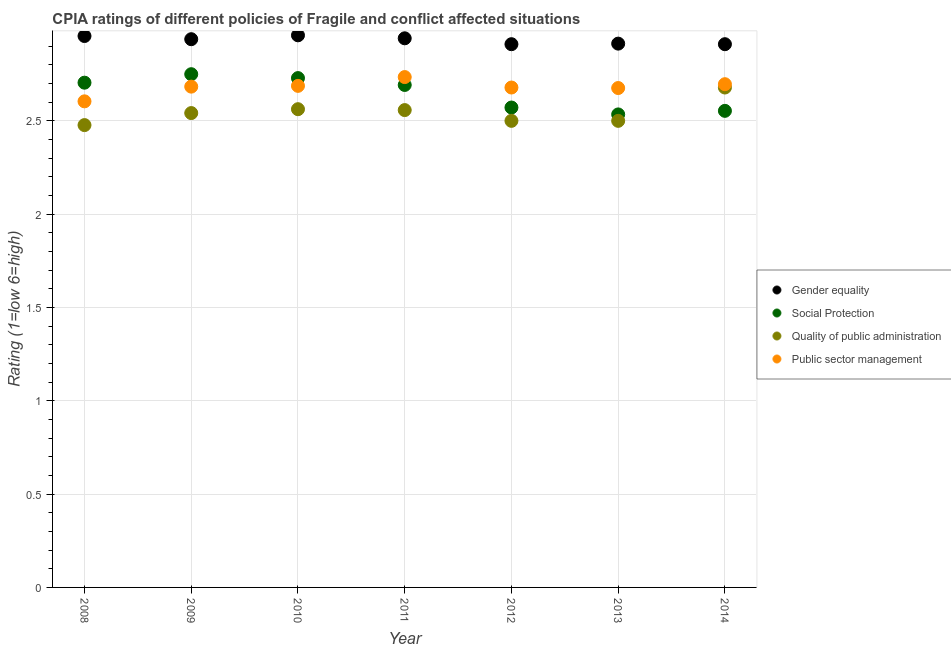How many different coloured dotlines are there?
Your response must be concise. 4. What is the cpia rating of gender equality in 2009?
Make the answer very short. 2.94. Across all years, what is the maximum cpia rating of public sector management?
Offer a terse response. 2.73. Across all years, what is the minimum cpia rating of gender equality?
Offer a terse response. 2.91. In which year was the cpia rating of gender equality maximum?
Your answer should be very brief. 2010. What is the total cpia rating of social protection in the graph?
Provide a succinct answer. 18.54. What is the difference between the cpia rating of social protection in 2011 and that in 2013?
Your response must be concise. 0.16. What is the average cpia rating of gender equality per year?
Provide a short and direct response. 2.93. In the year 2013, what is the difference between the cpia rating of social protection and cpia rating of quality of public administration?
Your answer should be very brief. 0.03. In how many years, is the cpia rating of quality of public administration greater than 2.7?
Provide a succinct answer. 0. What is the ratio of the cpia rating of public sector management in 2010 to that in 2012?
Your answer should be compact. 1. What is the difference between the highest and the second highest cpia rating of public sector management?
Provide a short and direct response. 0.04. What is the difference between the highest and the lowest cpia rating of social protection?
Offer a terse response. 0.22. Does the cpia rating of social protection monotonically increase over the years?
Your response must be concise. No. Is the cpia rating of public sector management strictly greater than the cpia rating of gender equality over the years?
Your answer should be very brief. No. Is the cpia rating of gender equality strictly less than the cpia rating of quality of public administration over the years?
Offer a very short reply. No. How many dotlines are there?
Your answer should be compact. 4. How many years are there in the graph?
Your response must be concise. 7. What is the difference between two consecutive major ticks on the Y-axis?
Ensure brevity in your answer.  0.5. Does the graph contain grids?
Your response must be concise. Yes. How many legend labels are there?
Ensure brevity in your answer.  4. How are the legend labels stacked?
Offer a terse response. Vertical. What is the title of the graph?
Your answer should be very brief. CPIA ratings of different policies of Fragile and conflict affected situations. Does "Regional development banks" appear as one of the legend labels in the graph?
Provide a short and direct response. No. What is the label or title of the X-axis?
Ensure brevity in your answer.  Year. What is the Rating (1=low 6=high) of Gender equality in 2008?
Provide a short and direct response. 2.95. What is the Rating (1=low 6=high) in Social Protection in 2008?
Provide a succinct answer. 2.7. What is the Rating (1=low 6=high) in Quality of public administration in 2008?
Your answer should be compact. 2.48. What is the Rating (1=low 6=high) in Public sector management in 2008?
Provide a succinct answer. 2.6. What is the Rating (1=low 6=high) in Gender equality in 2009?
Keep it short and to the point. 2.94. What is the Rating (1=low 6=high) in Social Protection in 2009?
Ensure brevity in your answer.  2.75. What is the Rating (1=low 6=high) in Quality of public administration in 2009?
Your response must be concise. 2.54. What is the Rating (1=low 6=high) in Public sector management in 2009?
Provide a short and direct response. 2.68. What is the Rating (1=low 6=high) in Gender equality in 2010?
Provide a short and direct response. 2.96. What is the Rating (1=low 6=high) in Social Protection in 2010?
Make the answer very short. 2.73. What is the Rating (1=low 6=high) of Quality of public administration in 2010?
Provide a short and direct response. 2.56. What is the Rating (1=low 6=high) of Public sector management in 2010?
Provide a short and direct response. 2.69. What is the Rating (1=low 6=high) of Gender equality in 2011?
Provide a succinct answer. 2.94. What is the Rating (1=low 6=high) of Social Protection in 2011?
Keep it short and to the point. 2.69. What is the Rating (1=low 6=high) of Quality of public administration in 2011?
Your answer should be compact. 2.56. What is the Rating (1=low 6=high) in Public sector management in 2011?
Give a very brief answer. 2.73. What is the Rating (1=low 6=high) of Gender equality in 2012?
Provide a succinct answer. 2.91. What is the Rating (1=low 6=high) of Social Protection in 2012?
Provide a succinct answer. 2.57. What is the Rating (1=low 6=high) in Public sector management in 2012?
Keep it short and to the point. 2.68. What is the Rating (1=low 6=high) in Gender equality in 2013?
Give a very brief answer. 2.91. What is the Rating (1=low 6=high) of Social Protection in 2013?
Your answer should be compact. 2.53. What is the Rating (1=low 6=high) in Public sector management in 2013?
Provide a succinct answer. 2.68. What is the Rating (1=low 6=high) in Gender equality in 2014?
Offer a terse response. 2.91. What is the Rating (1=low 6=high) of Social Protection in 2014?
Your answer should be very brief. 2.55. What is the Rating (1=low 6=high) of Quality of public administration in 2014?
Offer a very short reply. 2.68. What is the Rating (1=low 6=high) in Public sector management in 2014?
Your answer should be compact. 2.7. Across all years, what is the maximum Rating (1=low 6=high) in Gender equality?
Make the answer very short. 2.96. Across all years, what is the maximum Rating (1=low 6=high) in Social Protection?
Provide a succinct answer. 2.75. Across all years, what is the maximum Rating (1=low 6=high) of Quality of public administration?
Offer a very short reply. 2.68. Across all years, what is the maximum Rating (1=low 6=high) in Public sector management?
Give a very brief answer. 2.73. Across all years, what is the minimum Rating (1=low 6=high) of Gender equality?
Provide a succinct answer. 2.91. Across all years, what is the minimum Rating (1=low 6=high) of Social Protection?
Give a very brief answer. 2.53. Across all years, what is the minimum Rating (1=low 6=high) in Quality of public administration?
Ensure brevity in your answer.  2.48. Across all years, what is the minimum Rating (1=low 6=high) in Public sector management?
Keep it short and to the point. 2.6. What is the total Rating (1=low 6=high) of Gender equality in the graph?
Your answer should be very brief. 20.53. What is the total Rating (1=low 6=high) of Social Protection in the graph?
Give a very brief answer. 18.54. What is the total Rating (1=low 6=high) of Quality of public administration in the graph?
Make the answer very short. 17.82. What is the total Rating (1=low 6=high) in Public sector management in the graph?
Your answer should be very brief. 18.76. What is the difference between the Rating (1=low 6=high) of Gender equality in 2008 and that in 2009?
Ensure brevity in your answer.  0.02. What is the difference between the Rating (1=low 6=high) of Social Protection in 2008 and that in 2009?
Make the answer very short. -0.05. What is the difference between the Rating (1=low 6=high) in Quality of public administration in 2008 and that in 2009?
Give a very brief answer. -0.06. What is the difference between the Rating (1=low 6=high) in Public sector management in 2008 and that in 2009?
Your answer should be compact. -0.08. What is the difference between the Rating (1=low 6=high) of Gender equality in 2008 and that in 2010?
Your answer should be compact. -0. What is the difference between the Rating (1=low 6=high) of Social Protection in 2008 and that in 2010?
Your response must be concise. -0.02. What is the difference between the Rating (1=low 6=high) of Quality of public administration in 2008 and that in 2010?
Provide a short and direct response. -0.09. What is the difference between the Rating (1=low 6=high) of Public sector management in 2008 and that in 2010?
Offer a terse response. -0.08. What is the difference between the Rating (1=low 6=high) of Gender equality in 2008 and that in 2011?
Ensure brevity in your answer.  0.01. What is the difference between the Rating (1=low 6=high) of Social Protection in 2008 and that in 2011?
Your response must be concise. 0.01. What is the difference between the Rating (1=low 6=high) in Quality of public administration in 2008 and that in 2011?
Your answer should be very brief. -0.08. What is the difference between the Rating (1=low 6=high) in Public sector management in 2008 and that in 2011?
Make the answer very short. -0.13. What is the difference between the Rating (1=low 6=high) in Gender equality in 2008 and that in 2012?
Your answer should be very brief. 0.04. What is the difference between the Rating (1=low 6=high) in Social Protection in 2008 and that in 2012?
Keep it short and to the point. 0.13. What is the difference between the Rating (1=low 6=high) of Quality of public administration in 2008 and that in 2012?
Give a very brief answer. -0.02. What is the difference between the Rating (1=low 6=high) of Public sector management in 2008 and that in 2012?
Your answer should be compact. -0.07. What is the difference between the Rating (1=low 6=high) of Gender equality in 2008 and that in 2013?
Your answer should be very brief. 0.04. What is the difference between the Rating (1=low 6=high) of Social Protection in 2008 and that in 2013?
Provide a succinct answer. 0.17. What is the difference between the Rating (1=low 6=high) of Quality of public administration in 2008 and that in 2013?
Offer a terse response. -0.02. What is the difference between the Rating (1=low 6=high) of Public sector management in 2008 and that in 2013?
Offer a very short reply. -0.07. What is the difference between the Rating (1=low 6=high) in Gender equality in 2008 and that in 2014?
Your answer should be very brief. 0.04. What is the difference between the Rating (1=low 6=high) in Social Protection in 2008 and that in 2014?
Offer a terse response. 0.15. What is the difference between the Rating (1=low 6=high) in Quality of public administration in 2008 and that in 2014?
Provide a succinct answer. -0.2. What is the difference between the Rating (1=low 6=high) of Public sector management in 2008 and that in 2014?
Give a very brief answer. -0.09. What is the difference between the Rating (1=low 6=high) in Gender equality in 2009 and that in 2010?
Give a very brief answer. -0.02. What is the difference between the Rating (1=low 6=high) in Social Protection in 2009 and that in 2010?
Your answer should be very brief. 0.02. What is the difference between the Rating (1=low 6=high) of Quality of public administration in 2009 and that in 2010?
Offer a very short reply. -0.02. What is the difference between the Rating (1=low 6=high) of Public sector management in 2009 and that in 2010?
Provide a short and direct response. -0. What is the difference between the Rating (1=low 6=high) in Gender equality in 2009 and that in 2011?
Your answer should be compact. -0. What is the difference between the Rating (1=low 6=high) in Social Protection in 2009 and that in 2011?
Your answer should be compact. 0.06. What is the difference between the Rating (1=low 6=high) of Quality of public administration in 2009 and that in 2011?
Give a very brief answer. -0.02. What is the difference between the Rating (1=low 6=high) in Public sector management in 2009 and that in 2011?
Provide a short and direct response. -0.05. What is the difference between the Rating (1=low 6=high) in Gender equality in 2009 and that in 2012?
Your response must be concise. 0.03. What is the difference between the Rating (1=low 6=high) of Social Protection in 2009 and that in 2012?
Ensure brevity in your answer.  0.18. What is the difference between the Rating (1=low 6=high) in Quality of public administration in 2009 and that in 2012?
Your answer should be very brief. 0.04. What is the difference between the Rating (1=low 6=high) of Public sector management in 2009 and that in 2012?
Provide a succinct answer. 0. What is the difference between the Rating (1=low 6=high) in Gender equality in 2009 and that in 2013?
Give a very brief answer. 0.02. What is the difference between the Rating (1=low 6=high) of Social Protection in 2009 and that in 2013?
Your response must be concise. 0.22. What is the difference between the Rating (1=low 6=high) of Quality of public administration in 2009 and that in 2013?
Your answer should be very brief. 0.04. What is the difference between the Rating (1=low 6=high) of Public sector management in 2009 and that in 2013?
Offer a very short reply. 0.01. What is the difference between the Rating (1=low 6=high) in Gender equality in 2009 and that in 2014?
Your answer should be compact. 0.03. What is the difference between the Rating (1=low 6=high) of Social Protection in 2009 and that in 2014?
Provide a succinct answer. 0.2. What is the difference between the Rating (1=low 6=high) of Quality of public administration in 2009 and that in 2014?
Make the answer very short. -0.14. What is the difference between the Rating (1=low 6=high) of Public sector management in 2009 and that in 2014?
Your response must be concise. -0.01. What is the difference between the Rating (1=low 6=high) in Gender equality in 2010 and that in 2011?
Provide a short and direct response. 0.02. What is the difference between the Rating (1=low 6=high) in Social Protection in 2010 and that in 2011?
Your answer should be very brief. 0.04. What is the difference between the Rating (1=low 6=high) in Quality of public administration in 2010 and that in 2011?
Provide a short and direct response. 0. What is the difference between the Rating (1=low 6=high) in Public sector management in 2010 and that in 2011?
Keep it short and to the point. -0.05. What is the difference between the Rating (1=low 6=high) of Gender equality in 2010 and that in 2012?
Provide a succinct answer. 0.05. What is the difference between the Rating (1=low 6=high) in Social Protection in 2010 and that in 2012?
Your answer should be compact. 0.16. What is the difference between the Rating (1=low 6=high) of Quality of public administration in 2010 and that in 2012?
Your answer should be very brief. 0.06. What is the difference between the Rating (1=low 6=high) of Public sector management in 2010 and that in 2012?
Ensure brevity in your answer.  0.01. What is the difference between the Rating (1=low 6=high) in Gender equality in 2010 and that in 2013?
Offer a very short reply. 0.04. What is the difference between the Rating (1=low 6=high) of Social Protection in 2010 and that in 2013?
Your response must be concise. 0.19. What is the difference between the Rating (1=low 6=high) of Quality of public administration in 2010 and that in 2013?
Your answer should be very brief. 0.06. What is the difference between the Rating (1=low 6=high) of Public sector management in 2010 and that in 2013?
Offer a very short reply. 0.01. What is the difference between the Rating (1=low 6=high) in Gender equality in 2010 and that in 2014?
Keep it short and to the point. 0.05. What is the difference between the Rating (1=low 6=high) of Social Protection in 2010 and that in 2014?
Keep it short and to the point. 0.18. What is the difference between the Rating (1=low 6=high) of Quality of public administration in 2010 and that in 2014?
Ensure brevity in your answer.  -0.12. What is the difference between the Rating (1=low 6=high) in Public sector management in 2010 and that in 2014?
Give a very brief answer. -0.01. What is the difference between the Rating (1=low 6=high) of Gender equality in 2011 and that in 2012?
Provide a succinct answer. 0.03. What is the difference between the Rating (1=low 6=high) of Social Protection in 2011 and that in 2012?
Keep it short and to the point. 0.12. What is the difference between the Rating (1=low 6=high) of Quality of public administration in 2011 and that in 2012?
Make the answer very short. 0.06. What is the difference between the Rating (1=low 6=high) in Public sector management in 2011 and that in 2012?
Offer a terse response. 0.06. What is the difference between the Rating (1=low 6=high) in Gender equality in 2011 and that in 2013?
Your answer should be very brief. 0.03. What is the difference between the Rating (1=low 6=high) of Social Protection in 2011 and that in 2013?
Your answer should be very brief. 0.16. What is the difference between the Rating (1=low 6=high) in Quality of public administration in 2011 and that in 2013?
Offer a terse response. 0.06. What is the difference between the Rating (1=low 6=high) of Public sector management in 2011 and that in 2013?
Your answer should be compact. 0.06. What is the difference between the Rating (1=low 6=high) of Gender equality in 2011 and that in 2014?
Offer a terse response. 0.03. What is the difference between the Rating (1=low 6=high) of Social Protection in 2011 and that in 2014?
Your response must be concise. 0.14. What is the difference between the Rating (1=low 6=high) in Quality of public administration in 2011 and that in 2014?
Ensure brevity in your answer.  -0.12. What is the difference between the Rating (1=low 6=high) in Public sector management in 2011 and that in 2014?
Your response must be concise. 0.04. What is the difference between the Rating (1=low 6=high) of Gender equality in 2012 and that in 2013?
Give a very brief answer. -0. What is the difference between the Rating (1=low 6=high) in Social Protection in 2012 and that in 2013?
Offer a terse response. 0.04. What is the difference between the Rating (1=low 6=high) in Public sector management in 2012 and that in 2013?
Provide a succinct answer. 0. What is the difference between the Rating (1=low 6=high) of Social Protection in 2012 and that in 2014?
Your answer should be very brief. 0.02. What is the difference between the Rating (1=low 6=high) in Quality of public administration in 2012 and that in 2014?
Offer a very short reply. -0.18. What is the difference between the Rating (1=low 6=high) of Public sector management in 2012 and that in 2014?
Ensure brevity in your answer.  -0.02. What is the difference between the Rating (1=low 6=high) of Gender equality in 2013 and that in 2014?
Your answer should be compact. 0. What is the difference between the Rating (1=low 6=high) of Social Protection in 2013 and that in 2014?
Give a very brief answer. -0.02. What is the difference between the Rating (1=low 6=high) of Quality of public administration in 2013 and that in 2014?
Provide a short and direct response. -0.18. What is the difference between the Rating (1=low 6=high) in Public sector management in 2013 and that in 2014?
Ensure brevity in your answer.  -0.02. What is the difference between the Rating (1=low 6=high) in Gender equality in 2008 and the Rating (1=low 6=high) in Social Protection in 2009?
Offer a terse response. 0.2. What is the difference between the Rating (1=low 6=high) in Gender equality in 2008 and the Rating (1=low 6=high) in Quality of public administration in 2009?
Provide a short and direct response. 0.41. What is the difference between the Rating (1=low 6=high) in Gender equality in 2008 and the Rating (1=low 6=high) in Public sector management in 2009?
Provide a short and direct response. 0.27. What is the difference between the Rating (1=low 6=high) of Social Protection in 2008 and the Rating (1=low 6=high) of Quality of public administration in 2009?
Offer a terse response. 0.16. What is the difference between the Rating (1=low 6=high) of Social Protection in 2008 and the Rating (1=low 6=high) of Public sector management in 2009?
Your response must be concise. 0.02. What is the difference between the Rating (1=low 6=high) of Quality of public administration in 2008 and the Rating (1=low 6=high) of Public sector management in 2009?
Provide a succinct answer. -0.21. What is the difference between the Rating (1=low 6=high) of Gender equality in 2008 and the Rating (1=low 6=high) of Social Protection in 2010?
Your answer should be compact. 0.23. What is the difference between the Rating (1=low 6=high) of Gender equality in 2008 and the Rating (1=low 6=high) of Quality of public administration in 2010?
Provide a short and direct response. 0.39. What is the difference between the Rating (1=low 6=high) of Gender equality in 2008 and the Rating (1=low 6=high) of Public sector management in 2010?
Provide a succinct answer. 0.27. What is the difference between the Rating (1=low 6=high) of Social Protection in 2008 and the Rating (1=low 6=high) of Quality of public administration in 2010?
Your answer should be very brief. 0.14. What is the difference between the Rating (1=low 6=high) of Social Protection in 2008 and the Rating (1=low 6=high) of Public sector management in 2010?
Ensure brevity in your answer.  0.02. What is the difference between the Rating (1=low 6=high) in Quality of public administration in 2008 and the Rating (1=low 6=high) in Public sector management in 2010?
Offer a terse response. -0.21. What is the difference between the Rating (1=low 6=high) of Gender equality in 2008 and the Rating (1=low 6=high) of Social Protection in 2011?
Offer a terse response. 0.26. What is the difference between the Rating (1=low 6=high) of Gender equality in 2008 and the Rating (1=low 6=high) of Quality of public administration in 2011?
Provide a succinct answer. 0.4. What is the difference between the Rating (1=low 6=high) of Gender equality in 2008 and the Rating (1=low 6=high) of Public sector management in 2011?
Your response must be concise. 0.22. What is the difference between the Rating (1=low 6=high) of Social Protection in 2008 and the Rating (1=low 6=high) of Quality of public administration in 2011?
Ensure brevity in your answer.  0.15. What is the difference between the Rating (1=low 6=high) in Social Protection in 2008 and the Rating (1=low 6=high) in Public sector management in 2011?
Offer a very short reply. -0.03. What is the difference between the Rating (1=low 6=high) of Quality of public administration in 2008 and the Rating (1=low 6=high) of Public sector management in 2011?
Ensure brevity in your answer.  -0.26. What is the difference between the Rating (1=low 6=high) of Gender equality in 2008 and the Rating (1=low 6=high) of Social Protection in 2012?
Offer a terse response. 0.38. What is the difference between the Rating (1=low 6=high) in Gender equality in 2008 and the Rating (1=low 6=high) in Quality of public administration in 2012?
Offer a terse response. 0.45. What is the difference between the Rating (1=low 6=high) of Gender equality in 2008 and the Rating (1=low 6=high) of Public sector management in 2012?
Ensure brevity in your answer.  0.28. What is the difference between the Rating (1=low 6=high) in Social Protection in 2008 and the Rating (1=low 6=high) in Quality of public administration in 2012?
Keep it short and to the point. 0.2. What is the difference between the Rating (1=low 6=high) in Social Protection in 2008 and the Rating (1=low 6=high) in Public sector management in 2012?
Make the answer very short. 0.03. What is the difference between the Rating (1=low 6=high) of Quality of public administration in 2008 and the Rating (1=low 6=high) of Public sector management in 2012?
Your response must be concise. -0.2. What is the difference between the Rating (1=low 6=high) in Gender equality in 2008 and the Rating (1=low 6=high) in Social Protection in 2013?
Give a very brief answer. 0.42. What is the difference between the Rating (1=low 6=high) of Gender equality in 2008 and the Rating (1=low 6=high) of Quality of public administration in 2013?
Your answer should be compact. 0.45. What is the difference between the Rating (1=low 6=high) of Gender equality in 2008 and the Rating (1=low 6=high) of Public sector management in 2013?
Make the answer very short. 0.28. What is the difference between the Rating (1=low 6=high) in Social Protection in 2008 and the Rating (1=low 6=high) in Quality of public administration in 2013?
Offer a very short reply. 0.2. What is the difference between the Rating (1=low 6=high) of Social Protection in 2008 and the Rating (1=low 6=high) of Public sector management in 2013?
Your answer should be very brief. 0.03. What is the difference between the Rating (1=low 6=high) in Quality of public administration in 2008 and the Rating (1=low 6=high) in Public sector management in 2013?
Offer a very short reply. -0.2. What is the difference between the Rating (1=low 6=high) of Gender equality in 2008 and the Rating (1=low 6=high) of Social Protection in 2014?
Ensure brevity in your answer.  0.4. What is the difference between the Rating (1=low 6=high) in Gender equality in 2008 and the Rating (1=low 6=high) in Quality of public administration in 2014?
Offer a terse response. 0.28. What is the difference between the Rating (1=low 6=high) of Gender equality in 2008 and the Rating (1=low 6=high) of Public sector management in 2014?
Give a very brief answer. 0.26. What is the difference between the Rating (1=low 6=high) of Social Protection in 2008 and the Rating (1=low 6=high) of Quality of public administration in 2014?
Give a very brief answer. 0.03. What is the difference between the Rating (1=low 6=high) in Social Protection in 2008 and the Rating (1=low 6=high) in Public sector management in 2014?
Your answer should be very brief. 0.01. What is the difference between the Rating (1=low 6=high) in Quality of public administration in 2008 and the Rating (1=low 6=high) in Public sector management in 2014?
Offer a terse response. -0.22. What is the difference between the Rating (1=low 6=high) of Gender equality in 2009 and the Rating (1=low 6=high) of Social Protection in 2010?
Give a very brief answer. 0.21. What is the difference between the Rating (1=low 6=high) of Social Protection in 2009 and the Rating (1=low 6=high) of Quality of public administration in 2010?
Offer a very short reply. 0.19. What is the difference between the Rating (1=low 6=high) of Social Protection in 2009 and the Rating (1=low 6=high) of Public sector management in 2010?
Ensure brevity in your answer.  0.06. What is the difference between the Rating (1=low 6=high) of Quality of public administration in 2009 and the Rating (1=low 6=high) of Public sector management in 2010?
Ensure brevity in your answer.  -0.15. What is the difference between the Rating (1=low 6=high) in Gender equality in 2009 and the Rating (1=low 6=high) in Social Protection in 2011?
Offer a very short reply. 0.25. What is the difference between the Rating (1=low 6=high) of Gender equality in 2009 and the Rating (1=low 6=high) of Quality of public administration in 2011?
Keep it short and to the point. 0.38. What is the difference between the Rating (1=low 6=high) in Gender equality in 2009 and the Rating (1=low 6=high) in Public sector management in 2011?
Your answer should be very brief. 0.2. What is the difference between the Rating (1=low 6=high) in Social Protection in 2009 and the Rating (1=low 6=high) in Quality of public administration in 2011?
Make the answer very short. 0.19. What is the difference between the Rating (1=low 6=high) in Social Protection in 2009 and the Rating (1=low 6=high) in Public sector management in 2011?
Your answer should be compact. 0.02. What is the difference between the Rating (1=low 6=high) of Quality of public administration in 2009 and the Rating (1=low 6=high) of Public sector management in 2011?
Keep it short and to the point. -0.19. What is the difference between the Rating (1=low 6=high) of Gender equality in 2009 and the Rating (1=low 6=high) of Social Protection in 2012?
Provide a succinct answer. 0.37. What is the difference between the Rating (1=low 6=high) in Gender equality in 2009 and the Rating (1=low 6=high) in Quality of public administration in 2012?
Provide a succinct answer. 0.44. What is the difference between the Rating (1=low 6=high) in Gender equality in 2009 and the Rating (1=low 6=high) in Public sector management in 2012?
Provide a short and direct response. 0.26. What is the difference between the Rating (1=low 6=high) in Social Protection in 2009 and the Rating (1=low 6=high) in Quality of public administration in 2012?
Your answer should be compact. 0.25. What is the difference between the Rating (1=low 6=high) in Social Protection in 2009 and the Rating (1=low 6=high) in Public sector management in 2012?
Give a very brief answer. 0.07. What is the difference between the Rating (1=low 6=high) in Quality of public administration in 2009 and the Rating (1=low 6=high) in Public sector management in 2012?
Make the answer very short. -0.14. What is the difference between the Rating (1=low 6=high) in Gender equality in 2009 and the Rating (1=low 6=high) in Social Protection in 2013?
Offer a terse response. 0.4. What is the difference between the Rating (1=low 6=high) in Gender equality in 2009 and the Rating (1=low 6=high) in Quality of public administration in 2013?
Ensure brevity in your answer.  0.44. What is the difference between the Rating (1=low 6=high) of Gender equality in 2009 and the Rating (1=low 6=high) of Public sector management in 2013?
Your answer should be compact. 0.26. What is the difference between the Rating (1=low 6=high) in Social Protection in 2009 and the Rating (1=low 6=high) in Quality of public administration in 2013?
Provide a succinct answer. 0.25. What is the difference between the Rating (1=low 6=high) in Social Protection in 2009 and the Rating (1=low 6=high) in Public sector management in 2013?
Offer a very short reply. 0.07. What is the difference between the Rating (1=low 6=high) in Quality of public administration in 2009 and the Rating (1=low 6=high) in Public sector management in 2013?
Your response must be concise. -0.13. What is the difference between the Rating (1=low 6=high) of Gender equality in 2009 and the Rating (1=low 6=high) of Social Protection in 2014?
Provide a succinct answer. 0.38. What is the difference between the Rating (1=low 6=high) in Gender equality in 2009 and the Rating (1=low 6=high) in Quality of public administration in 2014?
Provide a short and direct response. 0.26. What is the difference between the Rating (1=low 6=high) of Gender equality in 2009 and the Rating (1=low 6=high) of Public sector management in 2014?
Your answer should be very brief. 0.24. What is the difference between the Rating (1=low 6=high) in Social Protection in 2009 and the Rating (1=low 6=high) in Quality of public administration in 2014?
Give a very brief answer. 0.07. What is the difference between the Rating (1=low 6=high) of Social Protection in 2009 and the Rating (1=low 6=high) of Public sector management in 2014?
Your response must be concise. 0.05. What is the difference between the Rating (1=low 6=high) in Quality of public administration in 2009 and the Rating (1=low 6=high) in Public sector management in 2014?
Your answer should be compact. -0.15. What is the difference between the Rating (1=low 6=high) of Gender equality in 2010 and the Rating (1=low 6=high) of Social Protection in 2011?
Offer a terse response. 0.27. What is the difference between the Rating (1=low 6=high) in Gender equality in 2010 and the Rating (1=low 6=high) in Quality of public administration in 2011?
Ensure brevity in your answer.  0.4. What is the difference between the Rating (1=low 6=high) in Gender equality in 2010 and the Rating (1=low 6=high) in Public sector management in 2011?
Keep it short and to the point. 0.22. What is the difference between the Rating (1=low 6=high) in Social Protection in 2010 and the Rating (1=low 6=high) in Quality of public administration in 2011?
Keep it short and to the point. 0.17. What is the difference between the Rating (1=low 6=high) in Social Protection in 2010 and the Rating (1=low 6=high) in Public sector management in 2011?
Your answer should be compact. -0.01. What is the difference between the Rating (1=low 6=high) in Quality of public administration in 2010 and the Rating (1=low 6=high) in Public sector management in 2011?
Provide a short and direct response. -0.17. What is the difference between the Rating (1=low 6=high) in Gender equality in 2010 and the Rating (1=low 6=high) in Social Protection in 2012?
Give a very brief answer. 0.39. What is the difference between the Rating (1=low 6=high) in Gender equality in 2010 and the Rating (1=low 6=high) in Quality of public administration in 2012?
Offer a terse response. 0.46. What is the difference between the Rating (1=low 6=high) in Gender equality in 2010 and the Rating (1=low 6=high) in Public sector management in 2012?
Your answer should be very brief. 0.28. What is the difference between the Rating (1=low 6=high) of Social Protection in 2010 and the Rating (1=low 6=high) of Quality of public administration in 2012?
Provide a short and direct response. 0.23. What is the difference between the Rating (1=low 6=high) in Social Protection in 2010 and the Rating (1=low 6=high) in Public sector management in 2012?
Ensure brevity in your answer.  0.05. What is the difference between the Rating (1=low 6=high) in Quality of public administration in 2010 and the Rating (1=low 6=high) in Public sector management in 2012?
Offer a very short reply. -0.12. What is the difference between the Rating (1=low 6=high) in Gender equality in 2010 and the Rating (1=low 6=high) in Social Protection in 2013?
Provide a short and direct response. 0.42. What is the difference between the Rating (1=low 6=high) of Gender equality in 2010 and the Rating (1=low 6=high) of Quality of public administration in 2013?
Offer a very short reply. 0.46. What is the difference between the Rating (1=low 6=high) in Gender equality in 2010 and the Rating (1=low 6=high) in Public sector management in 2013?
Provide a succinct answer. 0.28. What is the difference between the Rating (1=low 6=high) of Social Protection in 2010 and the Rating (1=low 6=high) of Quality of public administration in 2013?
Your answer should be very brief. 0.23. What is the difference between the Rating (1=low 6=high) of Social Protection in 2010 and the Rating (1=low 6=high) of Public sector management in 2013?
Provide a short and direct response. 0.05. What is the difference between the Rating (1=low 6=high) in Quality of public administration in 2010 and the Rating (1=low 6=high) in Public sector management in 2013?
Keep it short and to the point. -0.11. What is the difference between the Rating (1=low 6=high) in Gender equality in 2010 and the Rating (1=low 6=high) in Social Protection in 2014?
Your answer should be compact. 0.4. What is the difference between the Rating (1=low 6=high) in Gender equality in 2010 and the Rating (1=low 6=high) in Quality of public administration in 2014?
Your answer should be compact. 0.28. What is the difference between the Rating (1=low 6=high) of Gender equality in 2010 and the Rating (1=low 6=high) of Public sector management in 2014?
Offer a terse response. 0.26. What is the difference between the Rating (1=low 6=high) of Social Protection in 2010 and the Rating (1=low 6=high) of Quality of public administration in 2014?
Your response must be concise. 0.05. What is the difference between the Rating (1=low 6=high) of Social Protection in 2010 and the Rating (1=low 6=high) of Public sector management in 2014?
Keep it short and to the point. 0.03. What is the difference between the Rating (1=low 6=high) of Quality of public administration in 2010 and the Rating (1=low 6=high) of Public sector management in 2014?
Make the answer very short. -0.13. What is the difference between the Rating (1=low 6=high) of Gender equality in 2011 and the Rating (1=low 6=high) of Social Protection in 2012?
Your answer should be compact. 0.37. What is the difference between the Rating (1=low 6=high) of Gender equality in 2011 and the Rating (1=low 6=high) of Quality of public administration in 2012?
Ensure brevity in your answer.  0.44. What is the difference between the Rating (1=low 6=high) in Gender equality in 2011 and the Rating (1=low 6=high) in Public sector management in 2012?
Offer a very short reply. 0.26. What is the difference between the Rating (1=low 6=high) of Social Protection in 2011 and the Rating (1=low 6=high) of Quality of public administration in 2012?
Your answer should be compact. 0.19. What is the difference between the Rating (1=low 6=high) in Social Protection in 2011 and the Rating (1=low 6=high) in Public sector management in 2012?
Keep it short and to the point. 0.01. What is the difference between the Rating (1=low 6=high) in Quality of public administration in 2011 and the Rating (1=low 6=high) in Public sector management in 2012?
Give a very brief answer. -0.12. What is the difference between the Rating (1=low 6=high) of Gender equality in 2011 and the Rating (1=low 6=high) of Social Protection in 2013?
Your answer should be compact. 0.41. What is the difference between the Rating (1=low 6=high) in Gender equality in 2011 and the Rating (1=low 6=high) in Quality of public administration in 2013?
Keep it short and to the point. 0.44. What is the difference between the Rating (1=low 6=high) in Gender equality in 2011 and the Rating (1=low 6=high) in Public sector management in 2013?
Ensure brevity in your answer.  0.27. What is the difference between the Rating (1=low 6=high) of Social Protection in 2011 and the Rating (1=low 6=high) of Quality of public administration in 2013?
Offer a terse response. 0.19. What is the difference between the Rating (1=low 6=high) in Social Protection in 2011 and the Rating (1=low 6=high) in Public sector management in 2013?
Ensure brevity in your answer.  0.02. What is the difference between the Rating (1=low 6=high) of Quality of public administration in 2011 and the Rating (1=low 6=high) of Public sector management in 2013?
Your response must be concise. -0.12. What is the difference between the Rating (1=low 6=high) in Gender equality in 2011 and the Rating (1=low 6=high) in Social Protection in 2014?
Your answer should be compact. 0.39. What is the difference between the Rating (1=low 6=high) in Gender equality in 2011 and the Rating (1=low 6=high) in Quality of public administration in 2014?
Ensure brevity in your answer.  0.26. What is the difference between the Rating (1=low 6=high) of Gender equality in 2011 and the Rating (1=low 6=high) of Public sector management in 2014?
Your response must be concise. 0.25. What is the difference between the Rating (1=low 6=high) in Social Protection in 2011 and the Rating (1=low 6=high) in Quality of public administration in 2014?
Offer a terse response. 0.01. What is the difference between the Rating (1=low 6=high) of Social Protection in 2011 and the Rating (1=low 6=high) of Public sector management in 2014?
Keep it short and to the point. -0. What is the difference between the Rating (1=low 6=high) of Quality of public administration in 2011 and the Rating (1=low 6=high) of Public sector management in 2014?
Keep it short and to the point. -0.14. What is the difference between the Rating (1=low 6=high) in Gender equality in 2012 and the Rating (1=low 6=high) in Social Protection in 2013?
Your answer should be very brief. 0.38. What is the difference between the Rating (1=low 6=high) in Gender equality in 2012 and the Rating (1=low 6=high) in Quality of public administration in 2013?
Provide a short and direct response. 0.41. What is the difference between the Rating (1=low 6=high) in Gender equality in 2012 and the Rating (1=low 6=high) in Public sector management in 2013?
Your response must be concise. 0.23. What is the difference between the Rating (1=low 6=high) in Social Protection in 2012 and the Rating (1=low 6=high) in Quality of public administration in 2013?
Provide a succinct answer. 0.07. What is the difference between the Rating (1=low 6=high) in Social Protection in 2012 and the Rating (1=low 6=high) in Public sector management in 2013?
Give a very brief answer. -0.1. What is the difference between the Rating (1=low 6=high) in Quality of public administration in 2012 and the Rating (1=low 6=high) in Public sector management in 2013?
Your answer should be compact. -0.18. What is the difference between the Rating (1=low 6=high) in Gender equality in 2012 and the Rating (1=low 6=high) in Social Protection in 2014?
Give a very brief answer. 0.36. What is the difference between the Rating (1=low 6=high) of Gender equality in 2012 and the Rating (1=low 6=high) of Quality of public administration in 2014?
Provide a short and direct response. 0.23. What is the difference between the Rating (1=low 6=high) in Gender equality in 2012 and the Rating (1=low 6=high) in Public sector management in 2014?
Make the answer very short. 0.21. What is the difference between the Rating (1=low 6=high) in Social Protection in 2012 and the Rating (1=low 6=high) in Quality of public administration in 2014?
Keep it short and to the point. -0.11. What is the difference between the Rating (1=low 6=high) of Social Protection in 2012 and the Rating (1=low 6=high) of Public sector management in 2014?
Your response must be concise. -0.12. What is the difference between the Rating (1=low 6=high) of Quality of public administration in 2012 and the Rating (1=low 6=high) of Public sector management in 2014?
Your response must be concise. -0.2. What is the difference between the Rating (1=low 6=high) of Gender equality in 2013 and the Rating (1=low 6=high) of Social Protection in 2014?
Provide a short and direct response. 0.36. What is the difference between the Rating (1=low 6=high) in Gender equality in 2013 and the Rating (1=low 6=high) in Quality of public administration in 2014?
Your response must be concise. 0.24. What is the difference between the Rating (1=low 6=high) of Gender equality in 2013 and the Rating (1=low 6=high) of Public sector management in 2014?
Offer a terse response. 0.22. What is the difference between the Rating (1=low 6=high) in Social Protection in 2013 and the Rating (1=low 6=high) in Quality of public administration in 2014?
Offer a very short reply. -0.14. What is the difference between the Rating (1=low 6=high) in Social Protection in 2013 and the Rating (1=low 6=high) in Public sector management in 2014?
Your answer should be very brief. -0.16. What is the difference between the Rating (1=low 6=high) of Quality of public administration in 2013 and the Rating (1=low 6=high) of Public sector management in 2014?
Provide a short and direct response. -0.2. What is the average Rating (1=low 6=high) in Gender equality per year?
Ensure brevity in your answer.  2.93. What is the average Rating (1=low 6=high) in Social Protection per year?
Your answer should be compact. 2.65. What is the average Rating (1=low 6=high) in Quality of public administration per year?
Your answer should be very brief. 2.55. What is the average Rating (1=low 6=high) of Public sector management per year?
Your answer should be very brief. 2.68. In the year 2008, what is the difference between the Rating (1=low 6=high) of Gender equality and Rating (1=low 6=high) of Social Protection?
Your answer should be compact. 0.25. In the year 2008, what is the difference between the Rating (1=low 6=high) in Gender equality and Rating (1=low 6=high) in Quality of public administration?
Give a very brief answer. 0.48. In the year 2008, what is the difference between the Rating (1=low 6=high) of Gender equality and Rating (1=low 6=high) of Public sector management?
Ensure brevity in your answer.  0.35. In the year 2008, what is the difference between the Rating (1=low 6=high) of Social Protection and Rating (1=low 6=high) of Quality of public administration?
Offer a terse response. 0.23. In the year 2008, what is the difference between the Rating (1=low 6=high) in Quality of public administration and Rating (1=low 6=high) in Public sector management?
Keep it short and to the point. -0.13. In the year 2009, what is the difference between the Rating (1=low 6=high) in Gender equality and Rating (1=low 6=high) in Social Protection?
Make the answer very short. 0.19. In the year 2009, what is the difference between the Rating (1=low 6=high) in Gender equality and Rating (1=low 6=high) in Quality of public administration?
Offer a very short reply. 0.4. In the year 2009, what is the difference between the Rating (1=low 6=high) of Gender equality and Rating (1=low 6=high) of Public sector management?
Your response must be concise. 0.25. In the year 2009, what is the difference between the Rating (1=low 6=high) of Social Protection and Rating (1=low 6=high) of Quality of public administration?
Keep it short and to the point. 0.21. In the year 2009, what is the difference between the Rating (1=low 6=high) of Social Protection and Rating (1=low 6=high) of Public sector management?
Your response must be concise. 0.07. In the year 2009, what is the difference between the Rating (1=low 6=high) of Quality of public administration and Rating (1=low 6=high) of Public sector management?
Keep it short and to the point. -0.14. In the year 2010, what is the difference between the Rating (1=low 6=high) of Gender equality and Rating (1=low 6=high) of Social Protection?
Offer a terse response. 0.23. In the year 2010, what is the difference between the Rating (1=low 6=high) of Gender equality and Rating (1=low 6=high) of Quality of public administration?
Ensure brevity in your answer.  0.4. In the year 2010, what is the difference between the Rating (1=low 6=high) of Gender equality and Rating (1=low 6=high) of Public sector management?
Your response must be concise. 0.27. In the year 2010, what is the difference between the Rating (1=low 6=high) in Social Protection and Rating (1=low 6=high) in Public sector management?
Provide a short and direct response. 0.04. In the year 2010, what is the difference between the Rating (1=low 6=high) of Quality of public administration and Rating (1=low 6=high) of Public sector management?
Make the answer very short. -0.12. In the year 2011, what is the difference between the Rating (1=low 6=high) in Gender equality and Rating (1=low 6=high) in Quality of public administration?
Keep it short and to the point. 0.38. In the year 2011, what is the difference between the Rating (1=low 6=high) of Gender equality and Rating (1=low 6=high) of Public sector management?
Your answer should be compact. 0.21. In the year 2011, what is the difference between the Rating (1=low 6=high) of Social Protection and Rating (1=low 6=high) of Quality of public administration?
Offer a terse response. 0.13. In the year 2011, what is the difference between the Rating (1=low 6=high) in Social Protection and Rating (1=low 6=high) in Public sector management?
Provide a succinct answer. -0.04. In the year 2011, what is the difference between the Rating (1=low 6=high) of Quality of public administration and Rating (1=low 6=high) of Public sector management?
Your response must be concise. -0.18. In the year 2012, what is the difference between the Rating (1=low 6=high) in Gender equality and Rating (1=low 6=high) in Social Protection?
Make the answer very short. 0.34. In the year 2012, what is the difference between the Rating (1=low 6=high) in Gender equality and Rating (1=low 6=high) in Quality of public administration?
Make the answer very short. 0.41. In the year 2012, what is the difference between the Rating (1=low 6=high) in Gender equality and Rating (1=low 6=high) in Public sector management?
Your answer should be compact. 0.23. In the year 2012, what is the difference between the Rating (1=low 6=high) in Social Protection and Rating (1=low 6=high) in Quality of public administration?
Ensure brevity in your answer.  0.07. In the year 2012, what is the difference between the Rating (1=low 6=high) in Social Protection and Rating (1=low 6=high) in Public sector management?
Your response must be concise. -0.11. In the year 2012, what is the difference between the Rating (1=low 6=high) of Quality of public administration and Rating (1=low 6=high) of Public sector management?
Provide a succinct answer. -0.18. In the year 2013, what is the difference between the Rating (1=low 6=high) of Gender equality and Rating (1=low 6=high) of Social Protection?
Offer a very short reply. 0.38. In the year 2013, what is the difference between the Rating (1=low 6=high) in Gender equality and Rating (1=low 6=high) in Quality of public administration?
Provide a short and direct response. 0.41. In the year 2013, what is the difference between the Rating (1=low 6=high) of Gender equality and Rating (1=low 6=high) of Public sector management?
Ensure brevity in your answer.  0.24. In the year 2013, what is the difference between the Rating (1=low 6=high) of Social Protection and Rating (1=low 6=high) of Quality of public administration?
Provide a succinct answer. 0.03. In the year 2013, what is the difference between the Rating (1=low 6=high) in Social Protection and Rating (1=low 6=high) in Public sector management?
Your answer should be very brief. -0.14. In the year 2013, what is the difference between the Rating (1=low 6=high) of Quality of public administration and Rating (1=low 6=high) of Public sector management?
Offer a terse response. -0.18. In the year 2014, what is the difference between the Rating (1=low 6=high) in Gender equality and Rating (1=low 6=high) in Social Protection?
Ensure brevity in your answer.  0.36. In the year 2014, what is the difference between the Rating (1=low 6=high) in Gender equality and Rating (1=low 6=high) in Quality of public administration?
Your answer should be very brief. 0.23. In the year 2014, what is the difference between the Rating (1=low 6=high) of Gender equality and Rating (1=low 6=high) of Public sector management?
Make the answer very short. 0.21. In the year 2014, what is the difference between the Rating (1=low 6=high) of Social Protection and Rating (1=low 6=high) of Quality of public administration?
Your response must be concise. -0.12. In the year 2014, what is the difference between the Rating (1=low 6=high) of Social Protection and Rating (1=low 6=high) of Public sector management?
Provide a succinct answer. -0.14. In the year 2014, what is the difference between the Rating (1=low 6=high) in Quality of public administration and Rating (1=low 6=high) in Public sector management?
Provide a succinct answer. -0.02. What is the ratio of the Rating (1=low 6=high) in Gender equality in 2008 to that in 2009?
Provide a short and direct response. 1.01. What is the ratio of the Rating (1=low 6=high) in Social Protection in 2008 to that in 2009?
Ensure brevity in your answer.  0.98. What is the ratio of the Rating (1=low 6=high) of Quality of public administration in 2008 to that in 2009?
Make the answer very short. 0.97. What is the ratio of the Rating (1=low 6=high) of Public sector management in 2008 to that in 2009?
Offer a terse response. 0.97. What is the ratio of the Rating (1=low 6=high) of Gender equality in 2008 to that in 2010?
Ensure brevity in your answer.  1. What is the ratio of the Rating (1=low 6=high) of Social Protection in 2008 to that in 2010?
Offer a very short reply. 0.99. What is the ratio of the Rating (1=low 6=high) of Quality of public administration in 2008 to that in 2010?
Provide a succinct answer. 0.97. What is the ratio of the Rating (1=low 6=high) in Public sector management in 2008 to that in 2010?
Keep it short and to the point. 0.97. What is the ratio of the Rating (1=low 6=high) of Social Protection in 2008 to that in 2011?
Your answer should be very brief. 1. What is the ratio of the Rating (1=low 6=high) in Quality of public administration in 2008 to that in 2011?
Provide a short and direct response. 0.97. What is the ratio of the Rating (1=low 6=high) of Public sector management in 2008 to that in 2011?
Your answer should be compact. 0.95. What is the ratio of the Rating (1=low 6=high) of Gender equality in 2008 to that in 2012?
Keep it short and to the point. 1.02. What is the ratio of the Rating (1=low 6=high) of Social Protection in 2008 to that in 2012?
Offer a very short reply. 1.05. What is the ratio of the Rating (1=low 6=high) in Quality of public administration in 2008 to that in 2012?
Your response must be concise. 0.99. What is the ratio of the Rating (1=low 6=high) in Public sector management in 2008 to that in 2012?
Provide a short and direct response. 0.97. What is the ratio of the Rating (1=low 6=high) in Social Protection in 2008 to that in 2013?
Make the answer very short. 1.07. What is the ratio of the Rating (1=low 6=high) in Quality of public administration in 2008 to that in 2013?
Your answer should be very brief. 0.99. What is the ratio of the Rating (1=low 6=high) in Public sector management in 2008 to that in 2013?
Keep it short and to the point. 0.97. What is the ratio of the Rating (1=low 6=high) in Gender equality in 2008 to that in 2014?
Offer a terse response. 1.02. What is the ratio of the Rating (1=low 6=high) of Social Protection in 2008 to that in 2014?
Give a very brief answer. 1.06. What is the ratio of the Rating (1=low 6=high) of Quality of public administration in 2008 to that in 2014?
Make the answer very short. 0.92. What is the ratio of the Rating (1=low 6=high) of Public sector management in 2008 to that in 2014?
Your answer should be compact. 0.97. What is the ratio of the Rating (1=low 6=high) in Gender equality in 2009 to that in 2010?
Ensure brevity in your answer.  0.99. What is the ratio of the Rating (1=low 6=high) of Social Protection in 2009 to that in 2010?
Make the answer very short. 1.01. What is the ratio of the Rating (1=low 6=high) in Gender equality in 2009 to that in 2011?
Your answer should be compact. 1. What is the ratio of the Rating (1=low 6=high) of Social Protection in 2009 to that in 2011?
Your response must be concise. 1.02. What is the ratio of the Rating (1=low 6=high) of Quality of public administration in 2009 to that in 2011?
Offer a terse response. 0.99. What is the ratio of the Rating (1=low 6=high) of Public sector management in 2009 to that in 2011?
Give a very brief answer. 0.98. What is the ratio of the Rating (1=low 6=high) of Gender equality in 2009 to that in 2012?
Your answer should be compact. 1.01. What is the ratio of the Rating (1=low 6=high) of Social Protection in 2009 to that in 2012?
Provide a succinct answer. 1.07. What is the ratio of the Rating (1=low 6=high) of Quality of public administration in 2009 to that in 2012?
Your response must be concise. 1.02. What is the ratio of the Rating (1=low 6=high) in Social Protection in 2009 to that in 2013?
Your answer should be compact. 1.08. What is the ratio of the Rating (1=low 6=high) in Quality of public administration in 2009 to that in 2013?
Offer a terse response. 1.02. What is the ratio of the Rating (1=low 6=high) of Gender equality in 2009 to that in 2014?
Provide a succinct answer. 1.01. What is the ratio of the Rating (1=low 6=high) in Social Protection in 2009 to that in 2014?
Give a very brief answer. 1.08. What is the ratio of the Rating (1=low 6=high) of Quality of public administration in 2009 to that in 2014?
Your answer should be compact. 0.95. What is the ratio of the Rating (1=low 6=high) in Gender equality in 2010 to that in 2011?
Provide a succinct answer. 1.01. What is the ratio of the Rating (1=low 6=high) of Social Protection in 2010 to that in 2011?
Give a very brief answer. 1.01. What is the ratio of the Rating (1=low 6=high) of Quality of public administration in 2010 to that in 2011?
Provide a short and direct response. 1. What is the ratio of the Rating (1=low 6=high) of Public sector management in 2010 to that in 2011?
Ensure brevity in your answer.  0.98. What is the ratio of the Rating (1=low 6=high) in Gender equality in 2010 to that in 2012?
Ensure brevity in your answer.  1.02. What is the ratio of the Rating (1=low 6=high) of Social Protection in 2010 to that in 2012?
Provide a short and direct response. 1.06. What is the ratio of the Rating (1=low 6=high) in Quality of public administration in 2010 to that in 2012?
Provide a short and direct response. 1.02. What is the ratio of the Rating (1=low 6=high) in Gender equality in 2010 to that in 2013?
Your response must be concise. 1.02. What is the ratio of the Rating (1=low 6=high) of Social Protection in 2010 to that in 2013?
Your response must be concise. 1.08. What is the ratio of the Rating (1=low 6=high) in Gender equality in 2010 to that in 2014?
Ensure brevity in your answer.  1.02. What is the ratio of the Rating (1=low 6=high) in Social Protection in 2010 to that in 2014?
Your response must be concise. 1.07. What is the ratio of the Rating (1=low 6=high) of Quality of public administration in 2010 to that in 2014?
Your answer should be very brief. 0.96. What is the ratio of the Rating (1=low 6=high) of Gender equality in 2011 to that in 2012?
Keep it short and to the point. 1.01. What is the ratio of the Rating (1=low 6=high) of Social Protection in 2011 to that in 2012?
Keep it short and to the point. 1.05. What is the ratio of the Rating (1=low 6=high) in Quality of public administration in 2011 to that in 2012?
Provide a succinct answer. 1.02. What is the ratio of the Rating (1=low 6=high) of Public sector management in 2011 to that in 2012?
Give a very brief answer. 1.02. What is the ratio of the Rating (1=low 6=high) of Gender equality in 2011 to that in 2013?
Offer a terse response. 1.01. What is the ratio of the Rating (1=low 6=high) in Social Protection in 2011 to that in 2013?
Ensure brevity in your answer.  1.06. What is the ratio of the Rating (1=low 6=high) in Quality of public administration in 2011 to that in 2013?
Your response must be concise. 1.02. What is the ratio of the Rating (1=low 6=high) in Gender equality in 2011 to that in 2014?
Your answer should be very brief. 1.01. What is the ratio of the Rating (1=low 6=high) of Social Protection in 2011 to that in 2014?
Your answer should be very brief. 1.05. What is the ratio of the Rating (1=low 6=high) in Quality of public administration in 2011 to that in 2014?
Ensure brevity in your answer.  0.95. What is the ratio of the Rating (1=low 6=high) in Public sector management in 2011 to that in 2014?
Give a very brief answer. 1.01. What is the ratio of the Rating (1=low 6=high) in Social Protection in 2012 to that in 2013?
Your answer should be very brief. 1.01. What is the ratio of the Rating (1=low 6=high) of Gender equality in 2012 to that in 2014?
Your answer should be compact. 1. What is the ratio of the Rating (1=low 6=high) of Social Protection in 2012 to that in 2014?
Keep it short and to the point. 1.01. What is the ratio of the Rating (1=low 6=high) of Social Protection in 2013 to that in 2014?
Offer a terse response. 0.99. What is the difference between the highest and the second highest Rating (1=low 6=high) in Gender equality?
Your answer should be compact. 0. What is the difference between the highest and the second highest Rating (1=low 6=high) of Social Protection?
Give a very brief answer. 0.02. What is the difference between the highest and the second highest Rating (1=low 6=high) in Quality of public administration?
Make the answer very short. 0.12. What is the difference between the highest and the second highest Rating (1=low 6=high) of Public sector management?
Your answer should be very brief. 0.04. What is the difference between the highest and the lowest Rating (1=low 6=high) in Gender equality?
Your answer should be very brief. 0.05. What is the difference between the highest and the lowest Rating (1=low 6=high) of Social Protection?
Offer a terse response. 0.22. What is the difference between the highest and the lowest Rating (1=low 6=high) in Quality of public administration?
Offer a very short reply. 0.2. What is the difference between the highest and the lowest Rating (1=low 6=high) in Public sector management?
Provide a succinct answer. 0.13. 